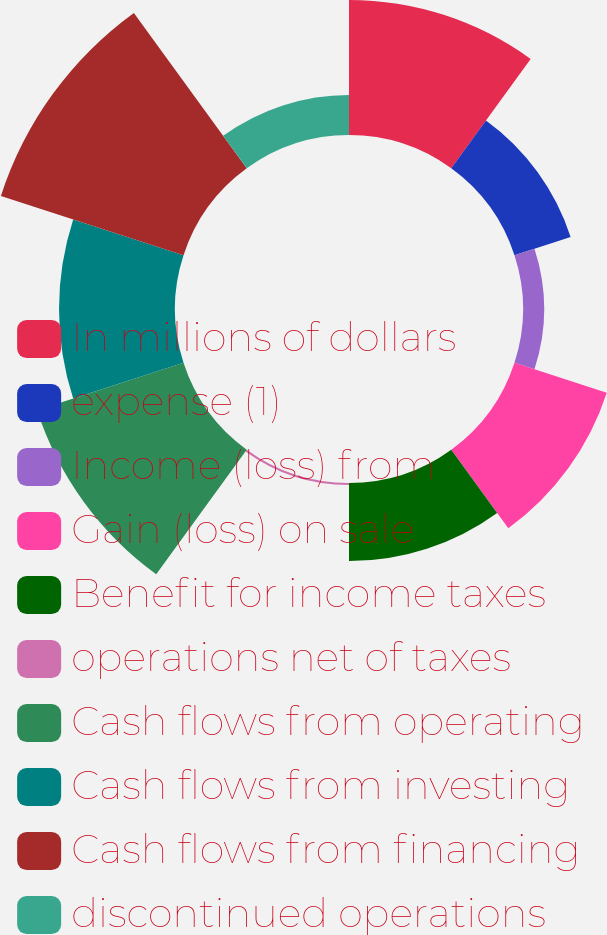Convert chart to OTSL. <chart><loc_0><loc_0><loc_500><loc_500><pie_chart><fcel>In millions of dollars<fcel>expense (1)<fcel>Income (loss) from<fcel>Gain (loss) on sale<fcel>Benefit for income taxes<fcel>operations net of taxes<fcel>Cash flows from operating<fcel>Cash flows from investing<fcel>Cash flows from financing<fcel>discontinued operations<nl><fcel>15.1%<fcel>6.6%<fcel>2.35%<fcel>10.85%<fcel>8.73%<fcel>0.23%<fcel>17.22%<fcel>12.97%<fcel>21.47%<fcel>4.48%<nl></chart> 